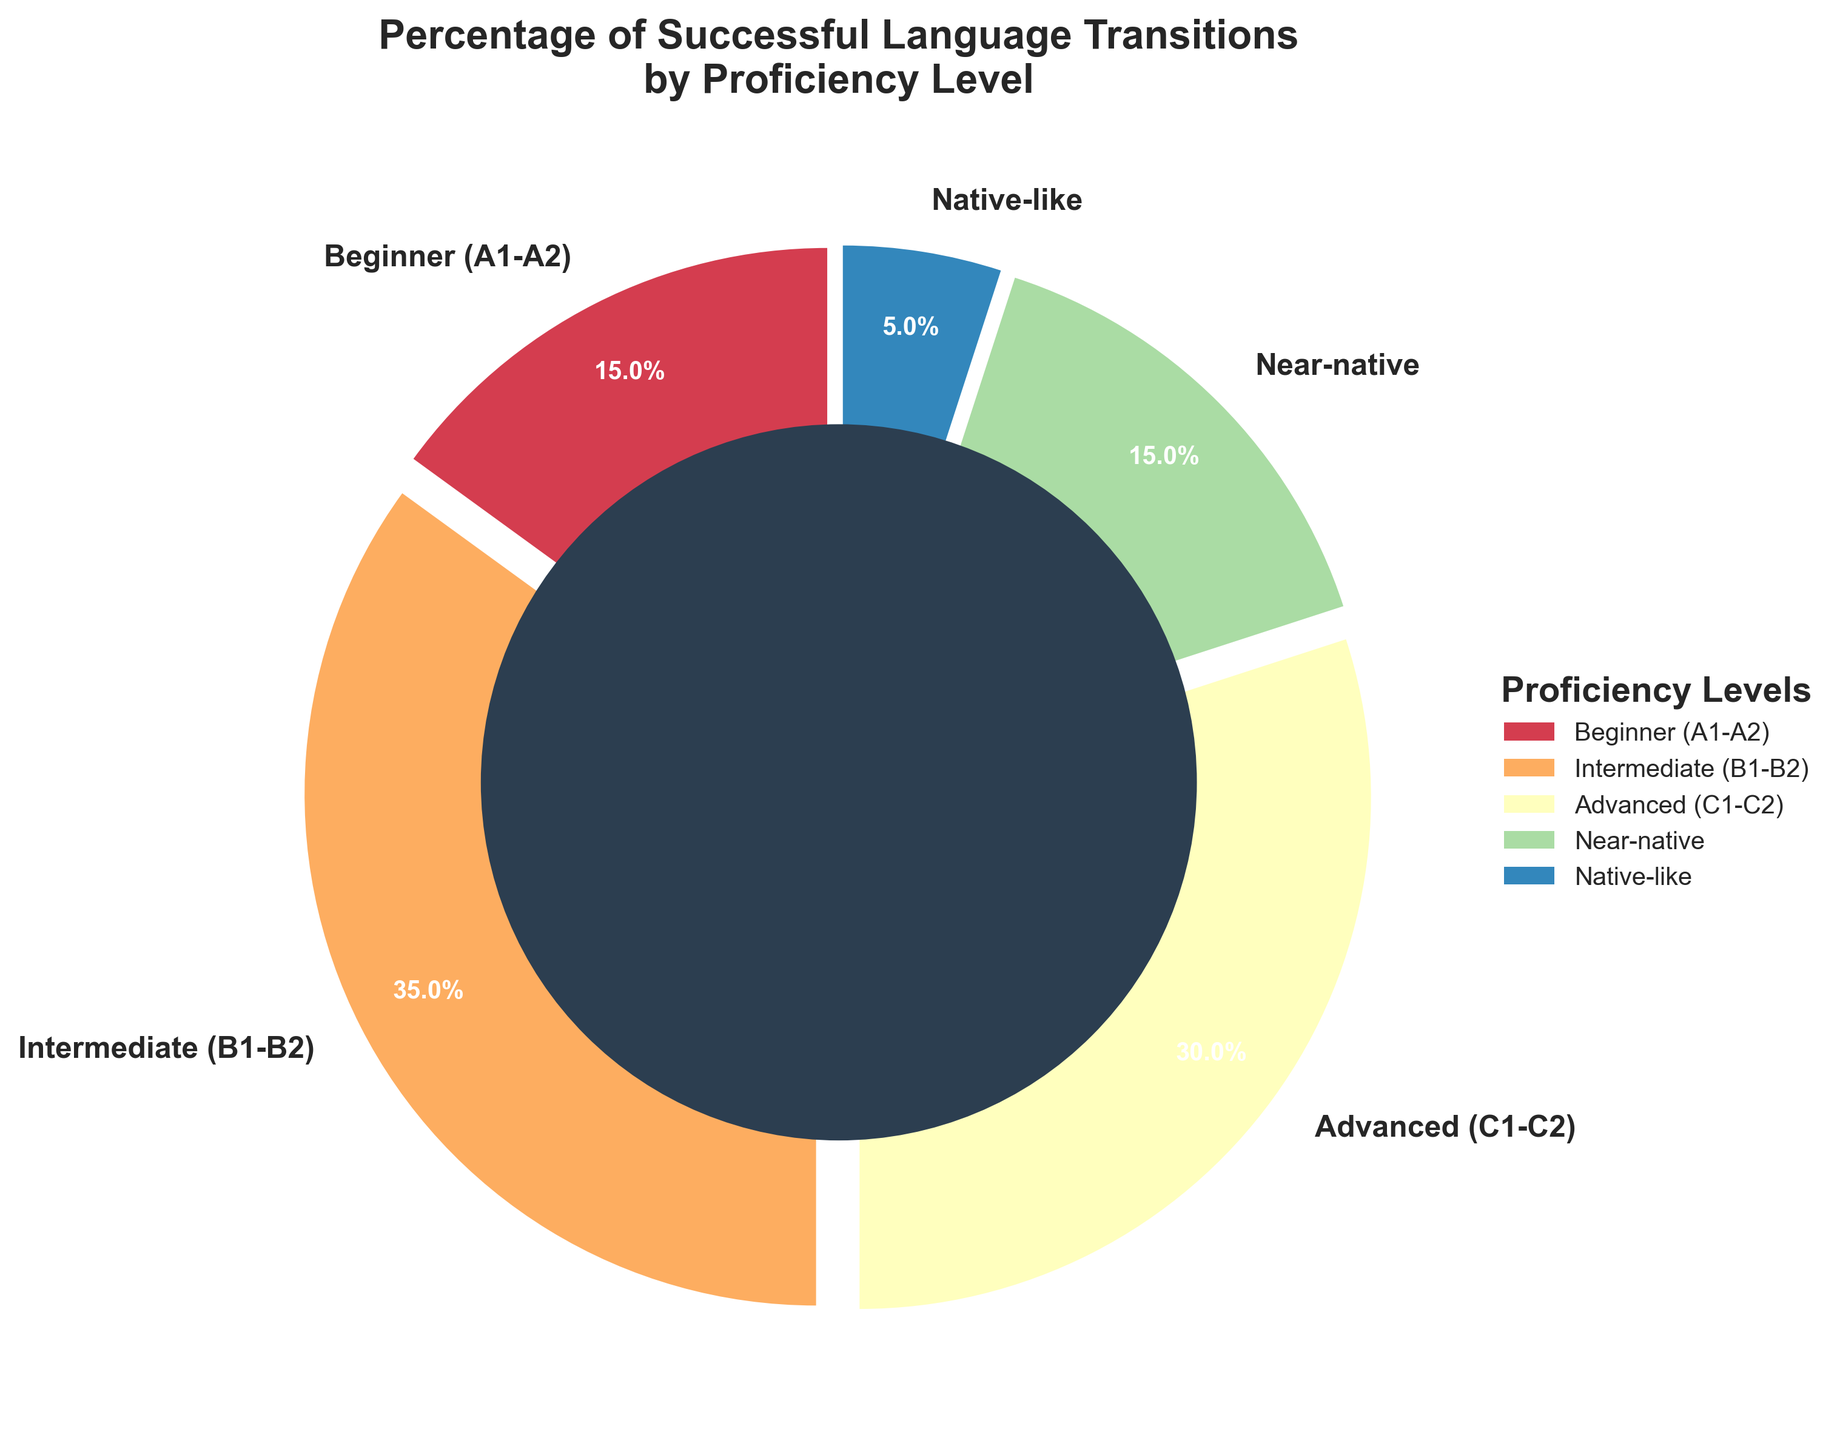What is the percentage of successful transitions for the Advanced (C1-C2) proficiency level? Looking at the pie chart, the segment labeled "Advanced (C1-C2)" represents 30% of successful transitions.
Answer: 30% Which proficiency level has the smallest percentage of successful transitions? By examining the size of the pie chart segments, the smallest segment is labeled "Native-like," representing 5% of successful transitions.
Answer: Native-like Between Intermediate (B1-B2) and Near-native proficiency levels, which one has a higher percentage of successful transitions, and by how much? From observing the chart, "Intermediate (B1-B2)" has 35% and "Near-native" has 15%. By subtracting these values, 35% - 15%, we find that the Intermediate level is higher by 20%.
Answer: Intermediate (B1-B2) by 20% What is the total percentage of successful transitions for proficiency levels below Advanced (C1-C2)? Adding the percentages for Beginner (15%), Intermediate (35%), and Near-native (15%), which are below Advanced: 15% + 35% + 15% = 65%.
Answer: 65% What percentage of successful transitions does the Beginner (A1-A2) proficiency level account for relative to the Native-like level? The percentages are 15% for Beginner and 5% for Native-like. The ratio is calculated as 15% / 5% = 3, meaning Beginner transitions are three times that of Native-like transitions.
Answer: 3 times Which two proficiency levels have an equal percentage of successful transitions? Observing the pie chart, the levels Beginner (A1-A2) and Near-native both show 15% successful transitions.
Answer: Beginner (A1-A2) and Near-native What is the average percentage of successful transitions for the Advanced (C1-C2) and Native-like proficiency levels? The percentages are 30% for Advanced and 5% for Native-like. Averaging these: (30% + 5%) / 2 = 17.5%.
Answer: 17.5% What is the total percentage of successful transitions accounted for by Beginner (A1-A2) and Intermediate (B1-B2) combined? Adding the percentages for Beginner (15%) and Intermediate (35%): 15% + 35% = 50%.
Answer: 50% What is the sum of the percentages of successful transitions for the top two proficiency levels with the highest percentages? The highest percentages are for Intermediate (35%) and Advanced (30%). Summing them: 35% + 30% = 65%.
Answer: 65% When adding the Advanced (C1-C2) and Native-like percentages together, how does this total compare to the percentage of successful transitions for Intermediate (B1-B2)? Adding Advanced (30%) and Native-like (5%): 30% + 5% = 35%. This is equal to the Intermediate percentage, which is also 35%.
Answer: Equal to Intermediate (B1-B2) 